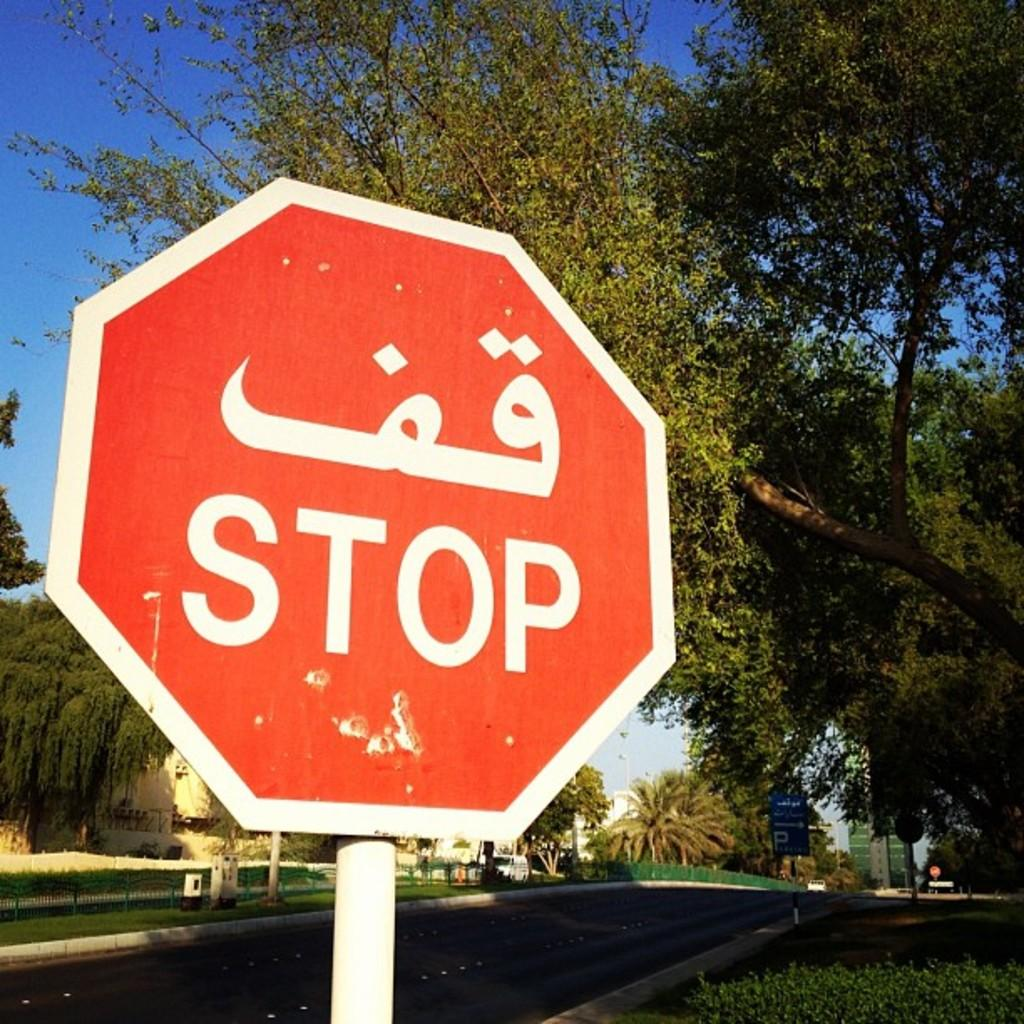<image>
Present a compact description of the photo's key features. A STOP sign is displayed on the street. 